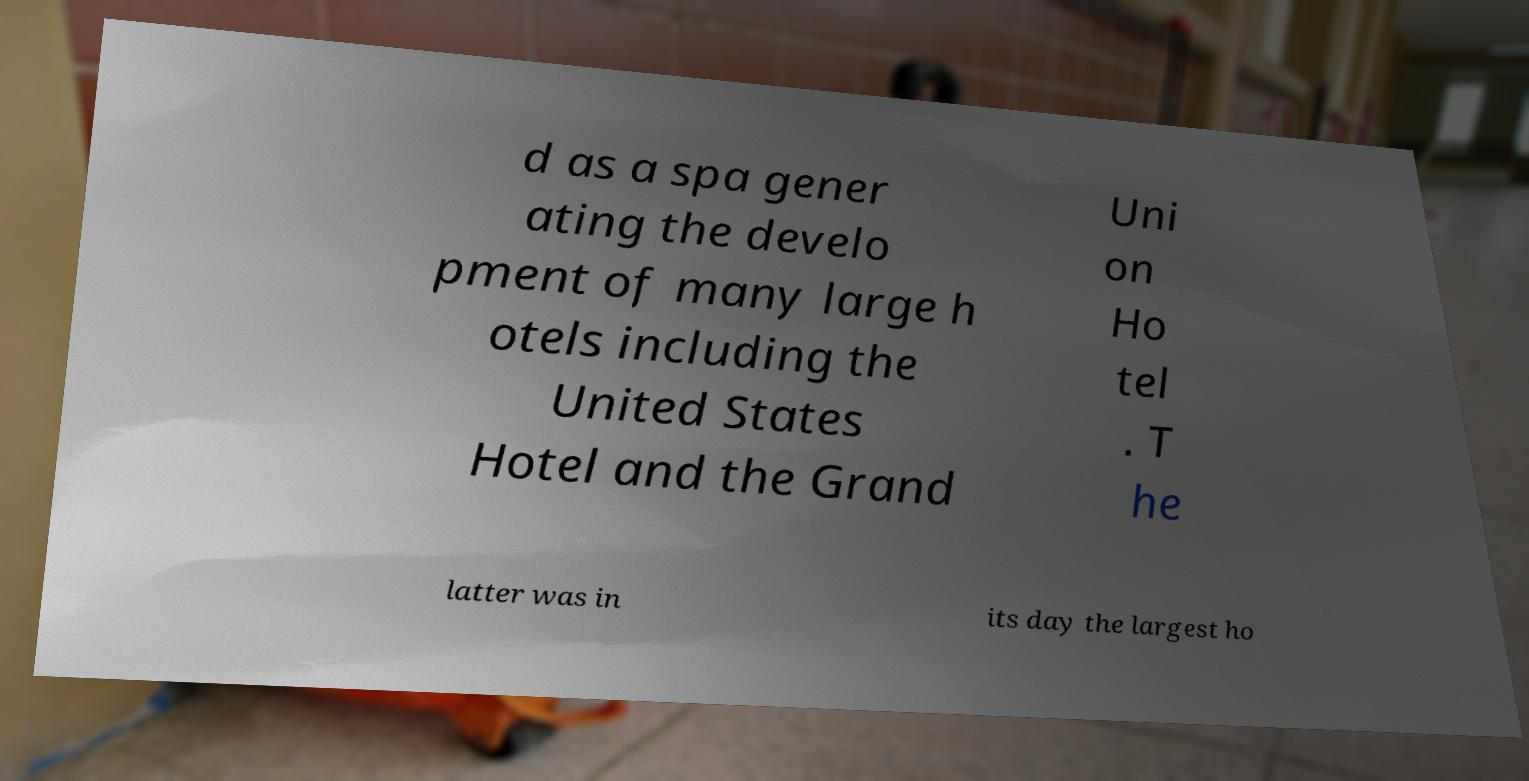Could you extract and type out the text from this image? d as a spa gener ating the develo pment of many large h otels including the United States Hotel and the Grand Uni on Ho tel . T he latter was in its day the largest ho 